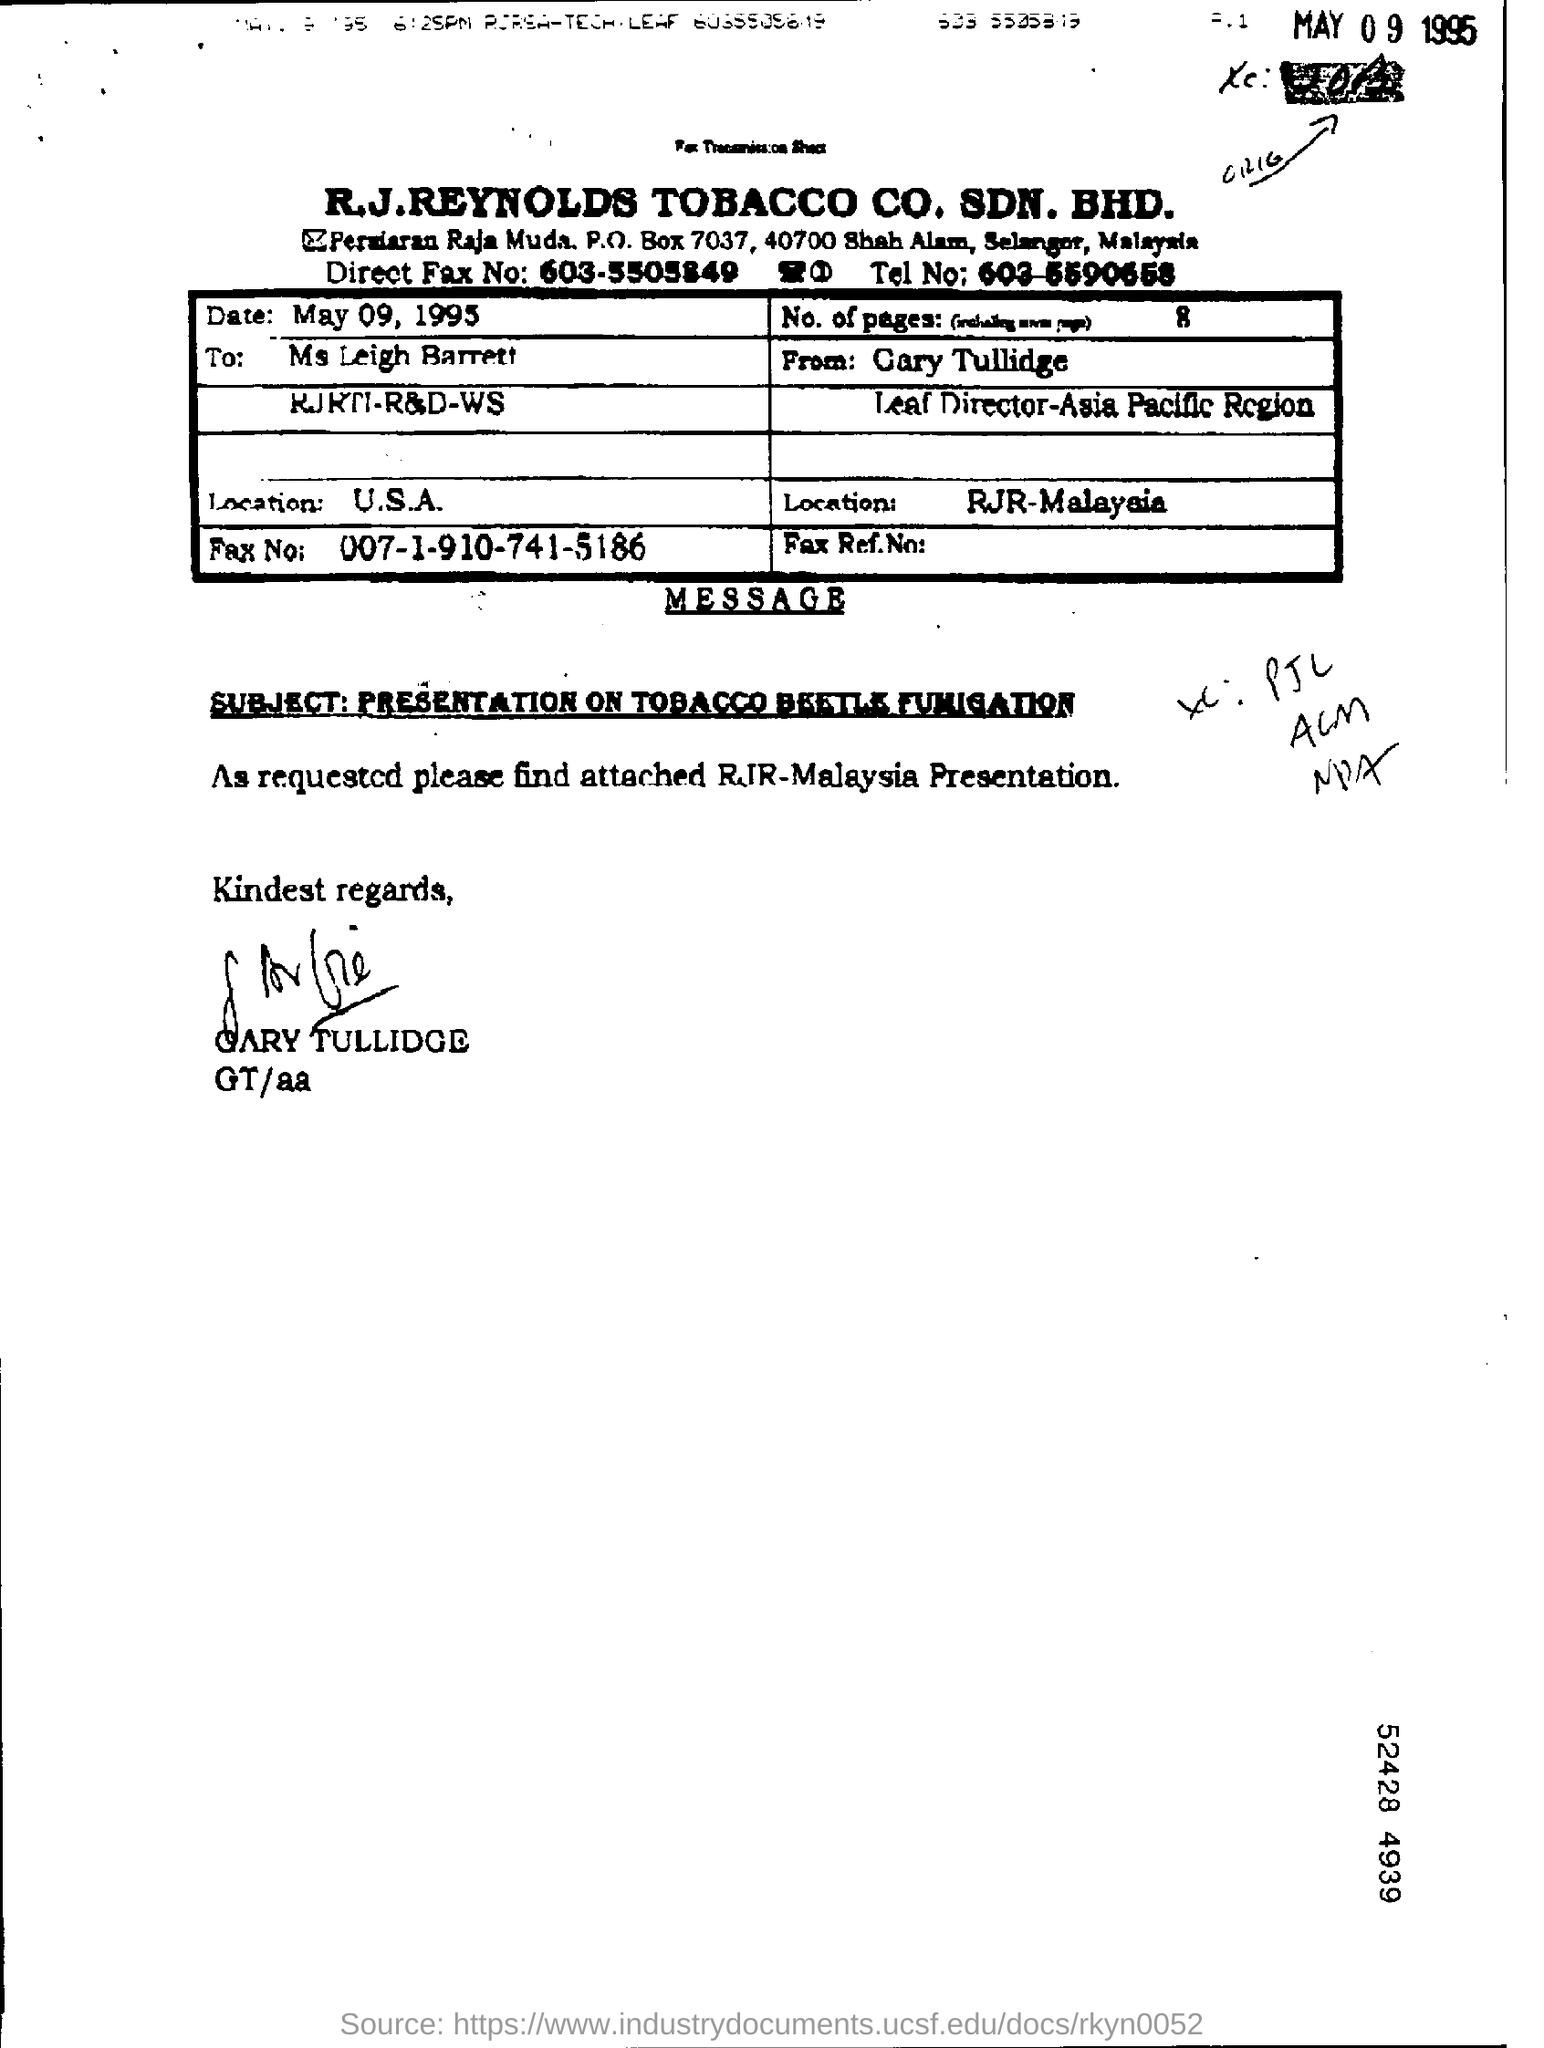What is the Date?
Ensure brevity in your answer.  May 09 , 1995. To whom is this letter addressed to?
Make the answer very short. Ms Leigh Barrett. What is the Fax No. for Ms Leigh Barrett?
Offer a very short reply. 007-1-910-741-5186. 